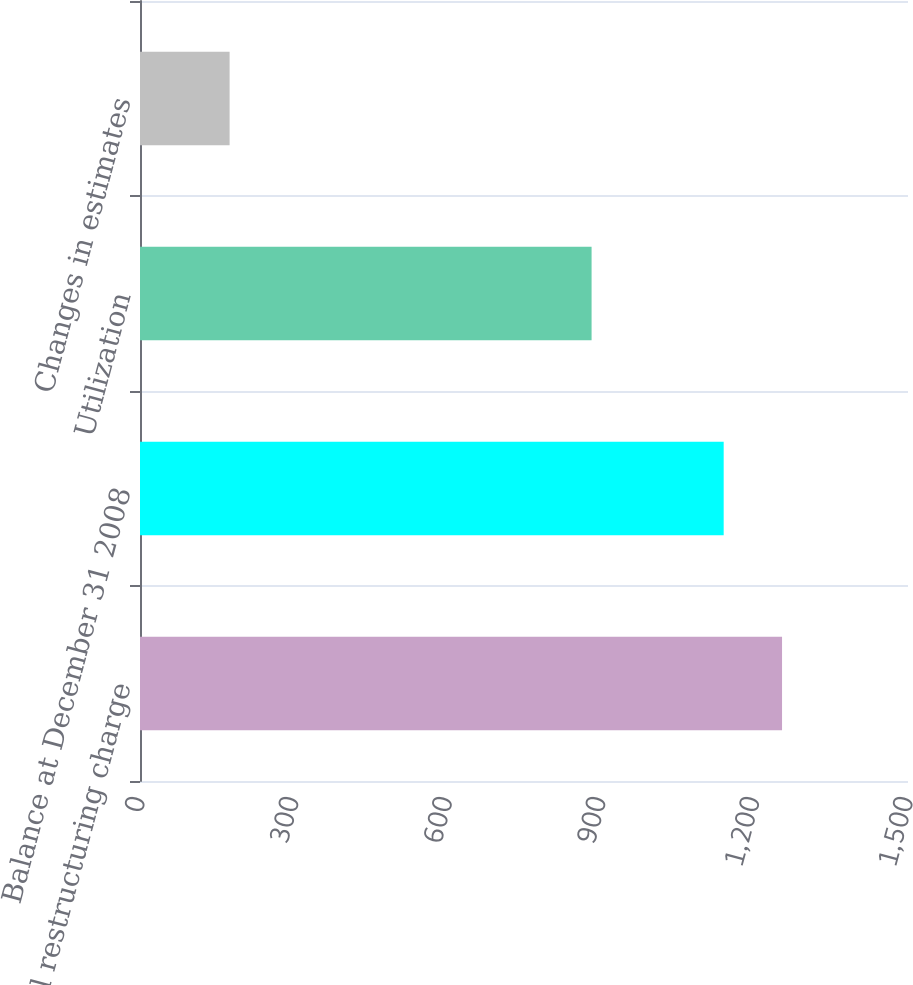Convert chart. <chart><loc_0><loc_0><loc_500><loc_500><bar_chart><fcel>Original restructuring charge<fcel>Balance at December 31 2008<fcel>Utilization<fcel>Changes in estimates<nl><fcel>1254<fcel>1140<fcel>882<fcel>175<nl></chart> 